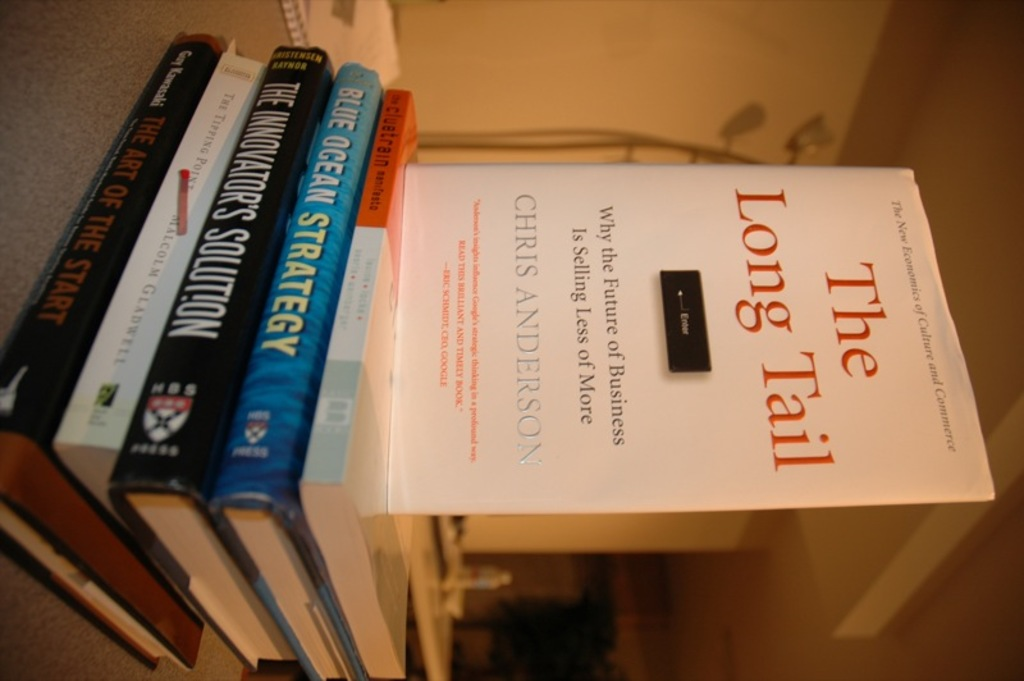How do 'The Innovator's Solution' and 'Blue Ocean Strategy' complement each other? Both 'The Innovator's Solution' and 'Blue Ocean Strategy' provide frameworks for overcoming competitive pressures and achieving business growth. While 'The Innovator's Solution' focuses on disruptive innovation for creating new markets, 'Blue Ocean Strategy' advocates creating new market spaces, termed 'Blue Oceans', where competition is irrelevant. Together, they offer a comprehensive approach to strategic planning and innovation. 